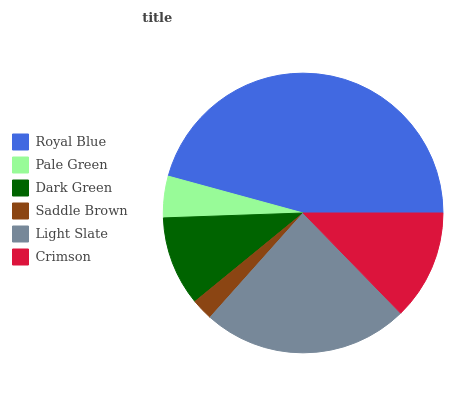Is Saddle Brown the minimum?
Answer yes or no. Yes. Is Royal Blue the maximum?
Answer yes or no. Yes. Is Pale Green the minimum?
Answer yes or no. No. Is Pale Green the maximum?
Answer yes or no. No. Is Royal Blue greater than Pale Green?
Answer yes or no. Yes. Is Pale Green less than Royal Blue?
Answer yes or no. Yes. Is Pale Green greater than Royal Blue?
Answer yes or no. No. Is Royal Blue less than Pale Green?
Answer yes or no. No. Is Crimson the high median?
Answer yes or no. Yes. Is Dark Green the low median?
Answer yes or no. Yes. Is Dark Green the high median?
Answer yes or no. No. Is Light Slate the low median?
Answer yes or no. No. 